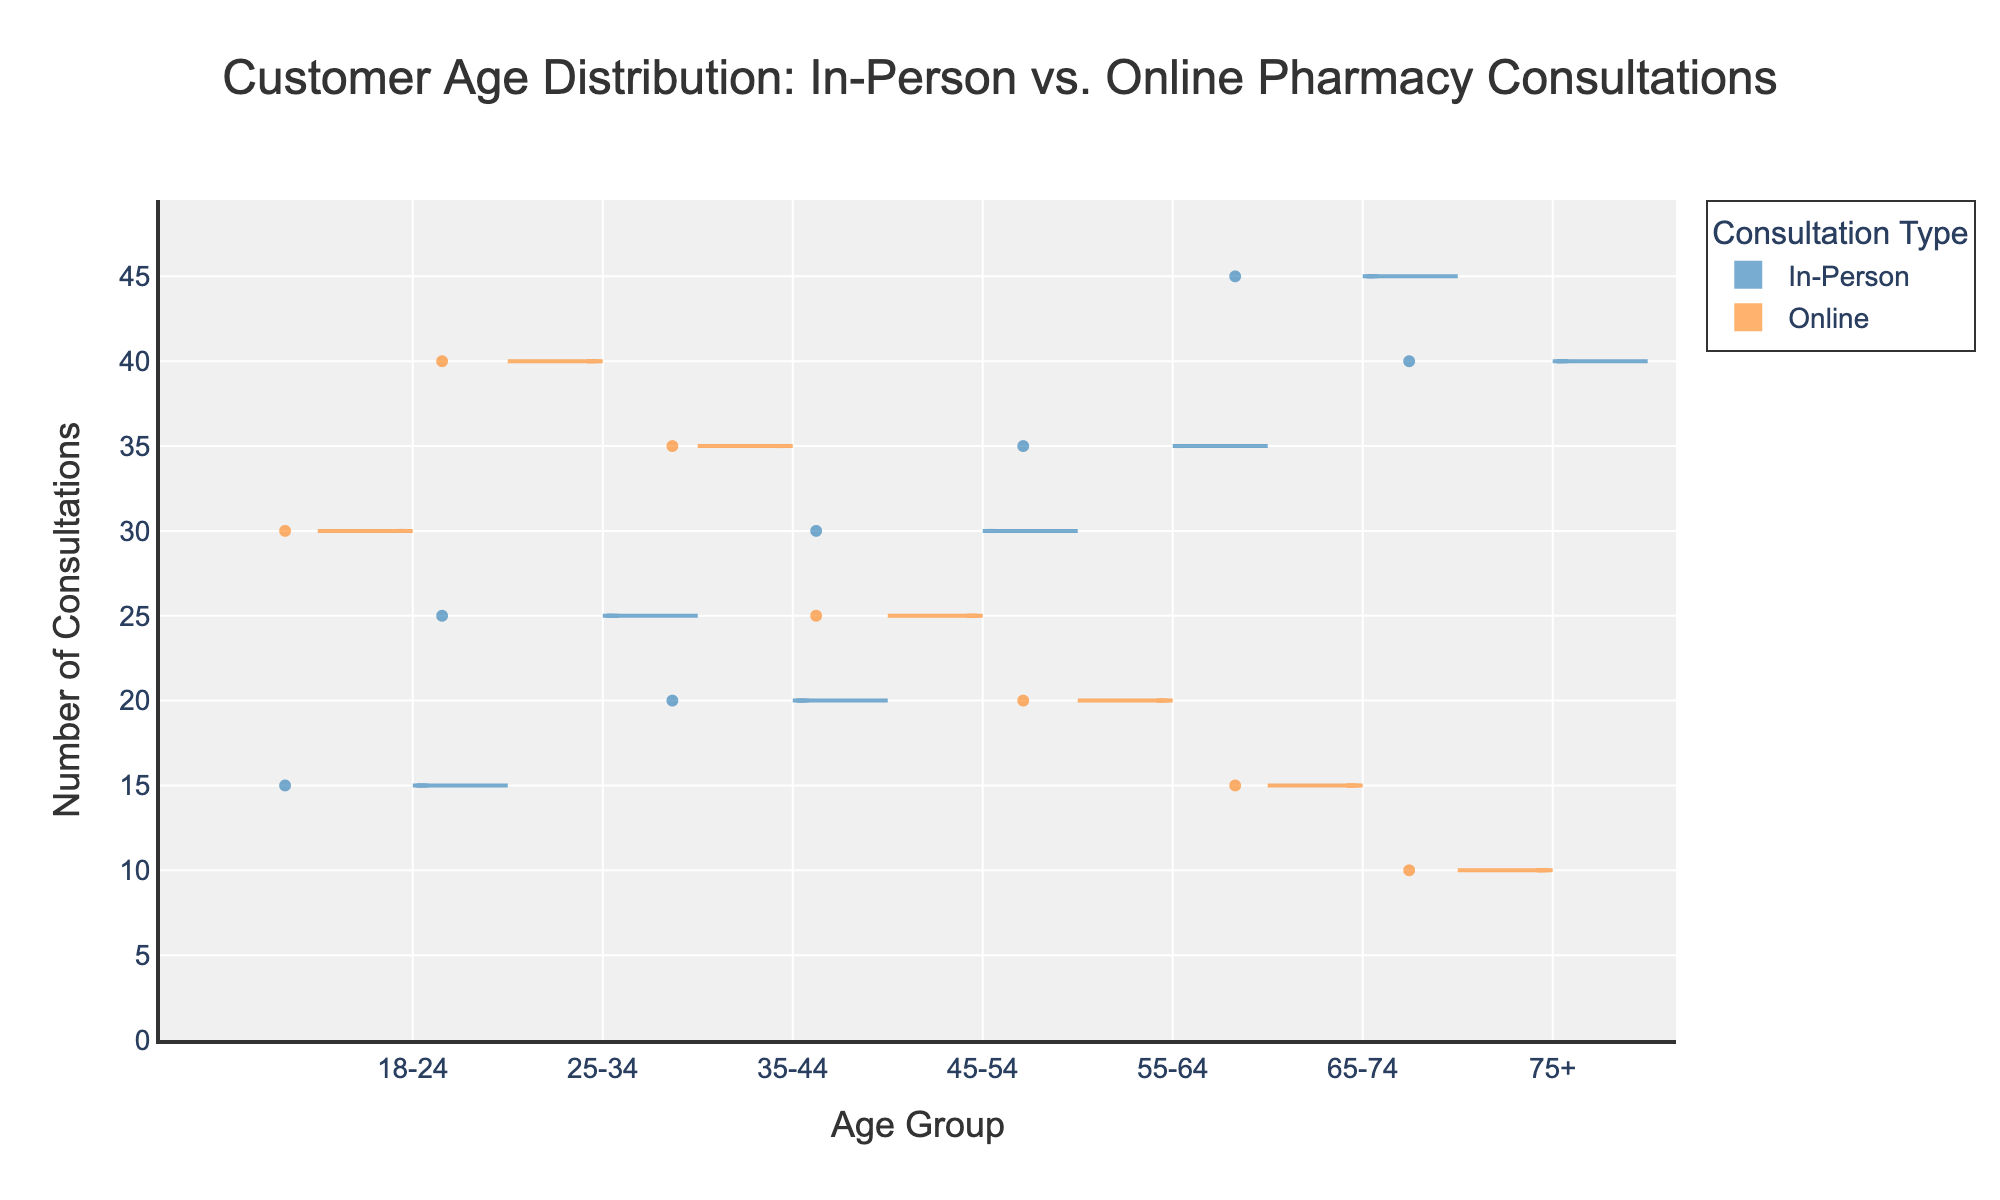What's the title of the chart? The title is the text at the top of the chart that describes what the chart is about. It states "Customer Age Distribution: In-Person vs. Online Pharmacy Consultations".
Answer: Customer Age Distribution: In-Person vs. Online Pharmacy Consultations Which age group has the highest number of in-person consultations? By looking at the figures for each age group on the "In-Person" side of the violin chart, the age group '65-74' has the highest count, with a total of 45 consultations.
Answer: 65-74 In the 35-44 age group, which type of consultation has more customers? By comparing the heights of the violins for 'In-Person' and 'Online' on the 35-44 age group, 'Online' has 35 consultations while 'In-Person' has 20.
Answer: Online What is the total number of consultations for the 55-64 age group? To find the total, sum the counts for 'In-Person' and 'Online' within the 55-64 age group. 35 (In-Person) + 20 (Online) = 55 consultations.
Answer: 55 How do the consultations compare in the 75+ age group between in-person and online? By comparing the heights of the violins, 'In-Person' in the 75+ age group has a total of 40 consultations, whereas 'Online' has only 10. 'In-Person' has more consultations.
Answer: In-Person Which consultation type has a more evenly distributed age range? By comparing the spread of the violins on both sides, the 'Online' consultation has a relatively more varied and even spread across different age groups, with consultations present in most age categories.
Answer: Online What's the difference in the number of consultations between 'In-Person' and 'Online' for the 18-24 age group? To find the difference, subtract the number of 'In-Person' consultations from 'Online' consultations within the 18-24 age group. 30 (Online) - 15 (In-Person) = 15.
Answer: 15 Which consultation type sees a higher number of consultations in the 45-54 age group? By comparing the figures for the 45-54 age group, the 'In-Person' consultations register 30 whereas the 'Online' has 25. Thus, 'In-Person' has a higher number.
Answer: In-Person How many more consultations does 'In-Person' have compared to 'Online' in the 65-74 age group? Subtract the count of 'Online' consultations from the count of 'In-Person' consultations for the 65-74 group. This equates to 45 (In-Person) - 15 (Online) = 30.
Answer: 30 